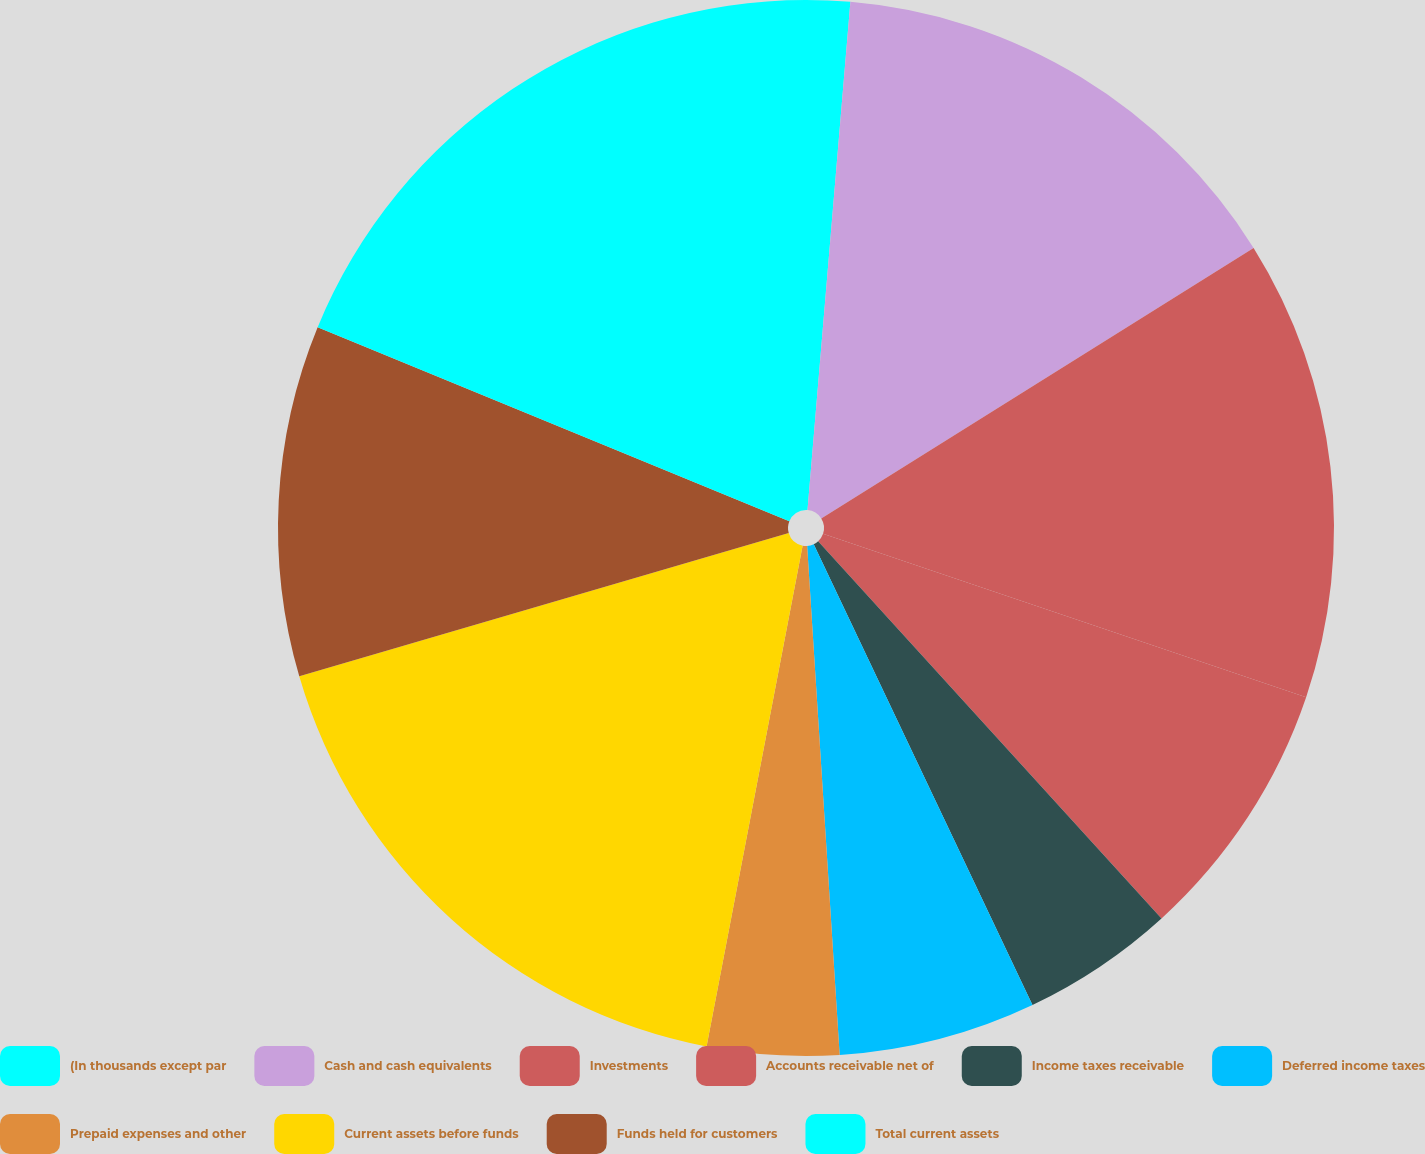Convert chart to OTSL. <chart><loc_0><loc_0><loc_500><loc_500><pie_chart><fcel>(In thousands except par<fcel>Cash and cash equivalents<fcel>Investments<fcel>Accounts receivable net of<fcel>Income taxes receivable<fcel>Deferred income taxes<fcel>Prepaid expenses and other<fcel>Current assets before funds<fcel>Funds held for customers<fcel>Total current assets<nl><fcel>1.34%<fcel>14.76%<fcel>14.09%<fcel>8.05%<fcel>4.7%<fcel>6.04%<fcel>4.03%<fcel>17.45%<fcel>10.74%<fcel>18.79%<nl></chart> 